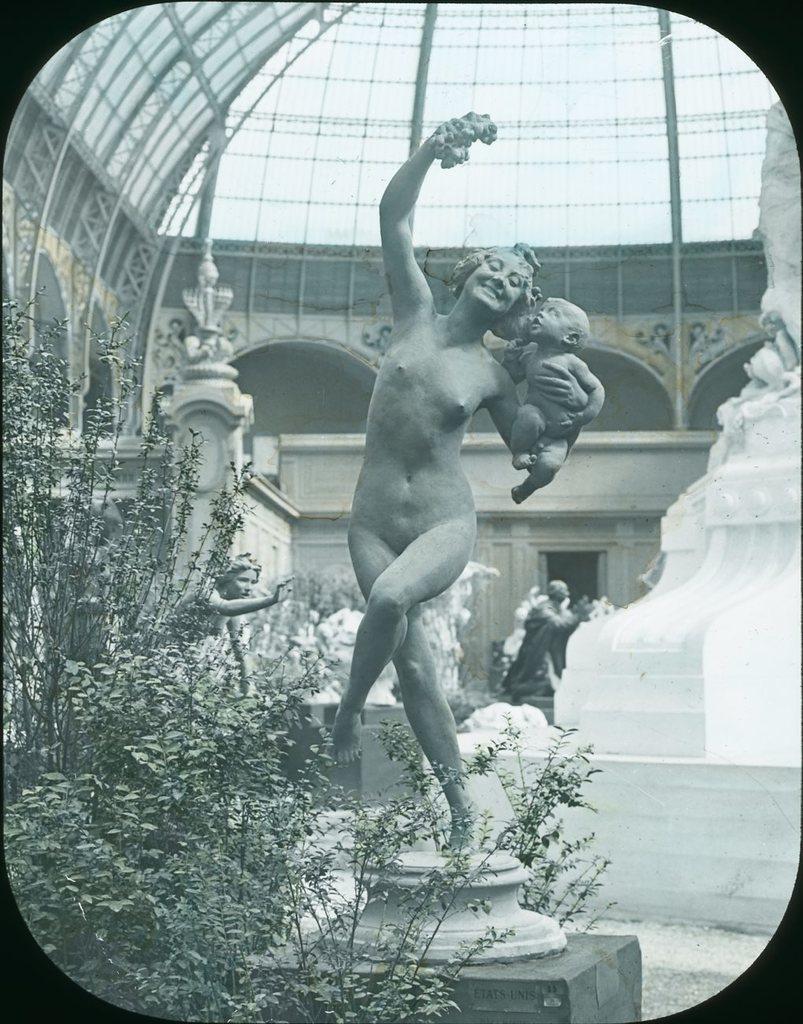Can you describe this image briefly? In this image I can see the black and white picture in which I can see few trees, few statues of persons. I can see a statue of a woman holding a baby. In the background I can see few trees, few statues, the wall and the ceiling. 